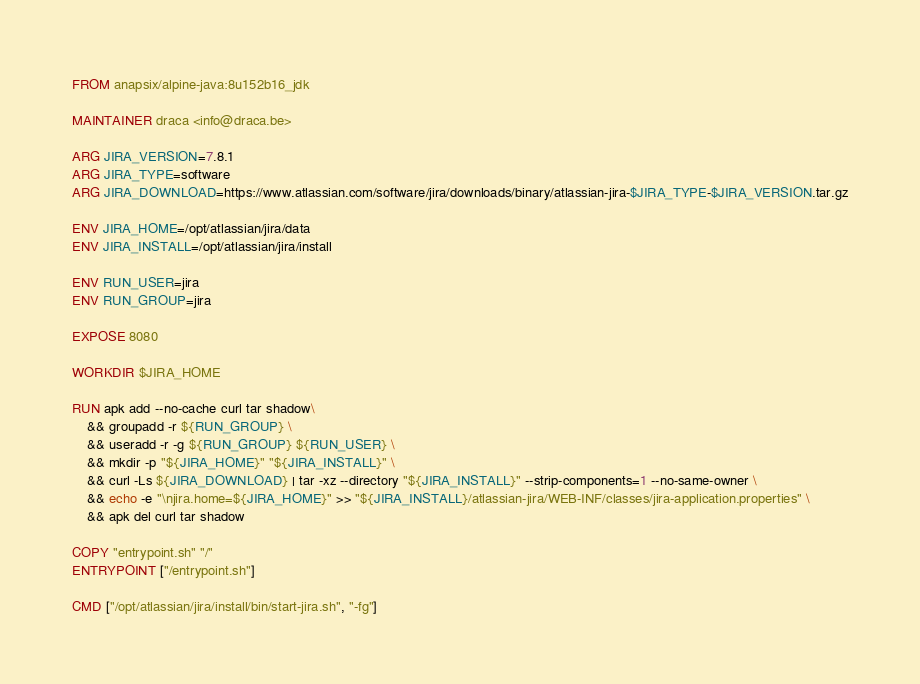Convert code to text. <code><loc_0><loc_0><loc_500><loc_500><_Dockerfile_>FROM anapsix/alpine-java:8u152b16_jdk

MAINTAINER draca <info@draca.be>

ARG JIRA_VERSION=7.8.1
ARG JIRA_TYPE=software
ARG JIRA_DOWNLOAD=https://www.atlassian.com/software/jira/downloads/binary/atlassian-jira-$JIRA_TYPE-$JIRA_VERSION.tar.gz

ENV JIRA_HOME=/opt/atlassian/jira/data
ENV JIRA_INSTALL=/opt/atlassian/jira/install

ENV RUN_USER=jira
ENV RUN_GROUP=jira

EXPOSE 8080

WORKDIR $JIRA_HOME

RUN apk add --no-cache curl tar shadow\
    && groupadd -r ${RUN_GROUP} \
    && useradd -r -g ${RUN_GROUP} ${RUN_USER} \
    && mkdir -p "${JIRA_HOME}" "${JIRA_INSTALL}" \
    && curl -Ls ${JIRA_DOWNLOAD} | tar -xz --directory "${JIRA_INSTALL}" --strip-components=1 --no-same-owner \
    && echo -e "\njira.home=${JIRA_HOME}" >> "${JIRA_INSTALL}/atlassian-jira/WEB-INF/classes/jira-application.properties" \
    && apk del curl tar shadow

COPY "entrypoint.sh" "/"
ENTRYPOINT ["/entrypoint.sh"]

CMD ["/opt/atlassian/jira/install/bin/start-jira.sh", "-fg"]
</code> 